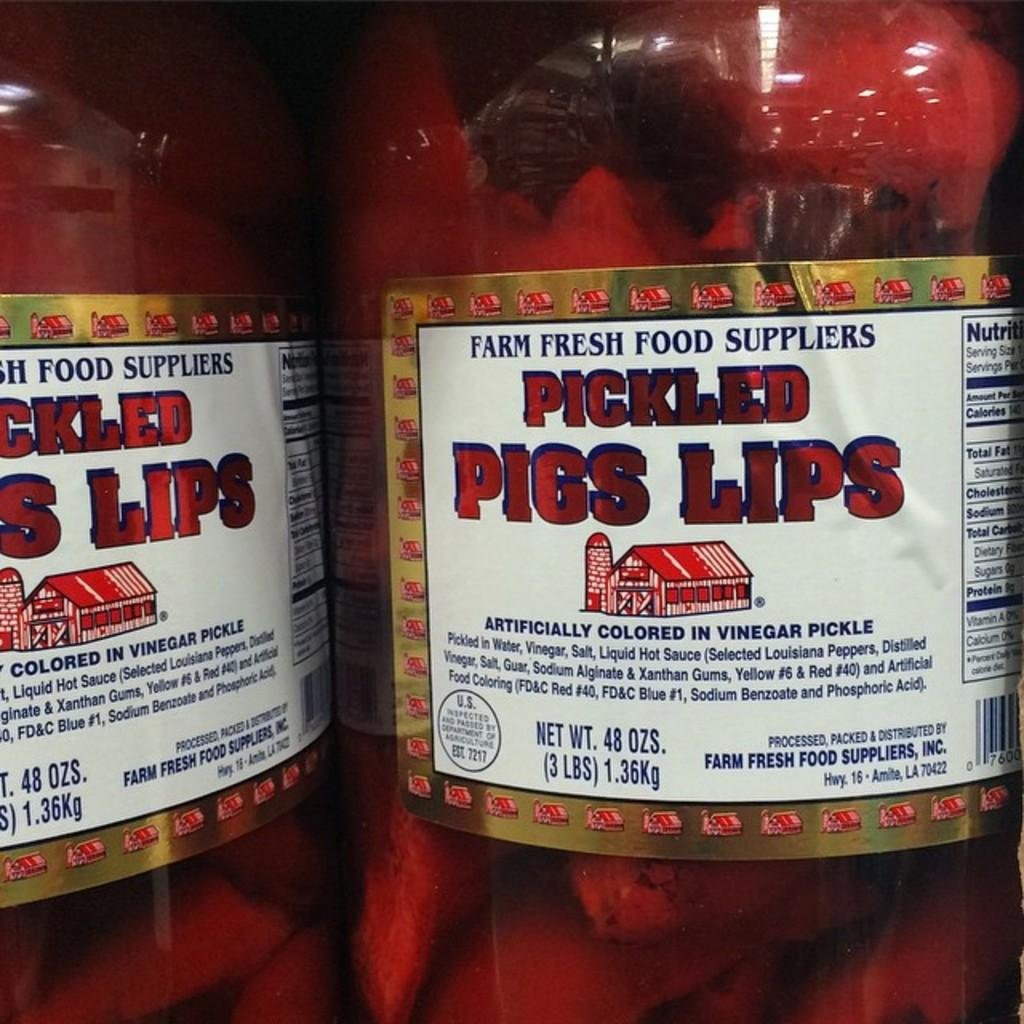How many bottles are visible in the image? There are two bottles in the image. Are there any distinguishing features on any of the bottles? Yes, one of the bottles has a sticker on it. Can you see any goats in the image? No, there are no goats present in the image. What is the weather like in the image, and how might it affect the pigs? There is no information about the weather or pigs in the image, as it only features two bottles, one with a sticker. 